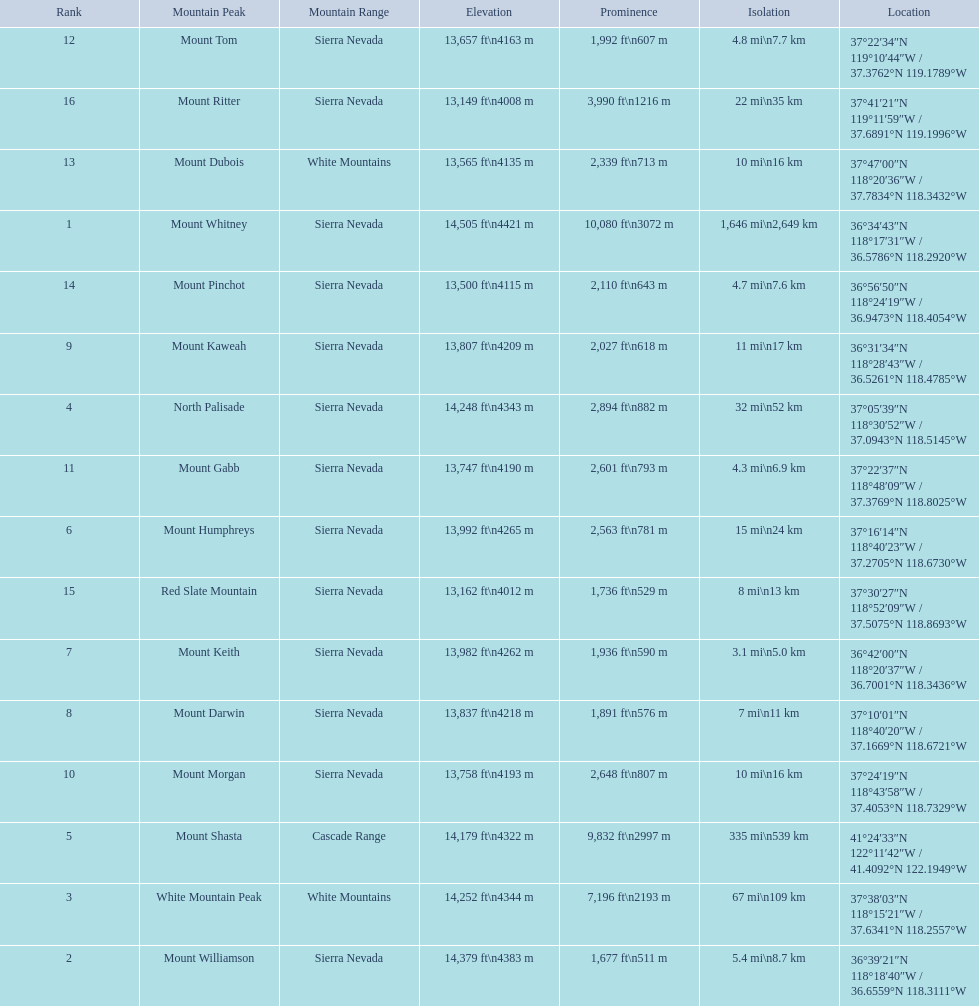What is the only mountain peak listed for the cascade range? Mount Shasta. 